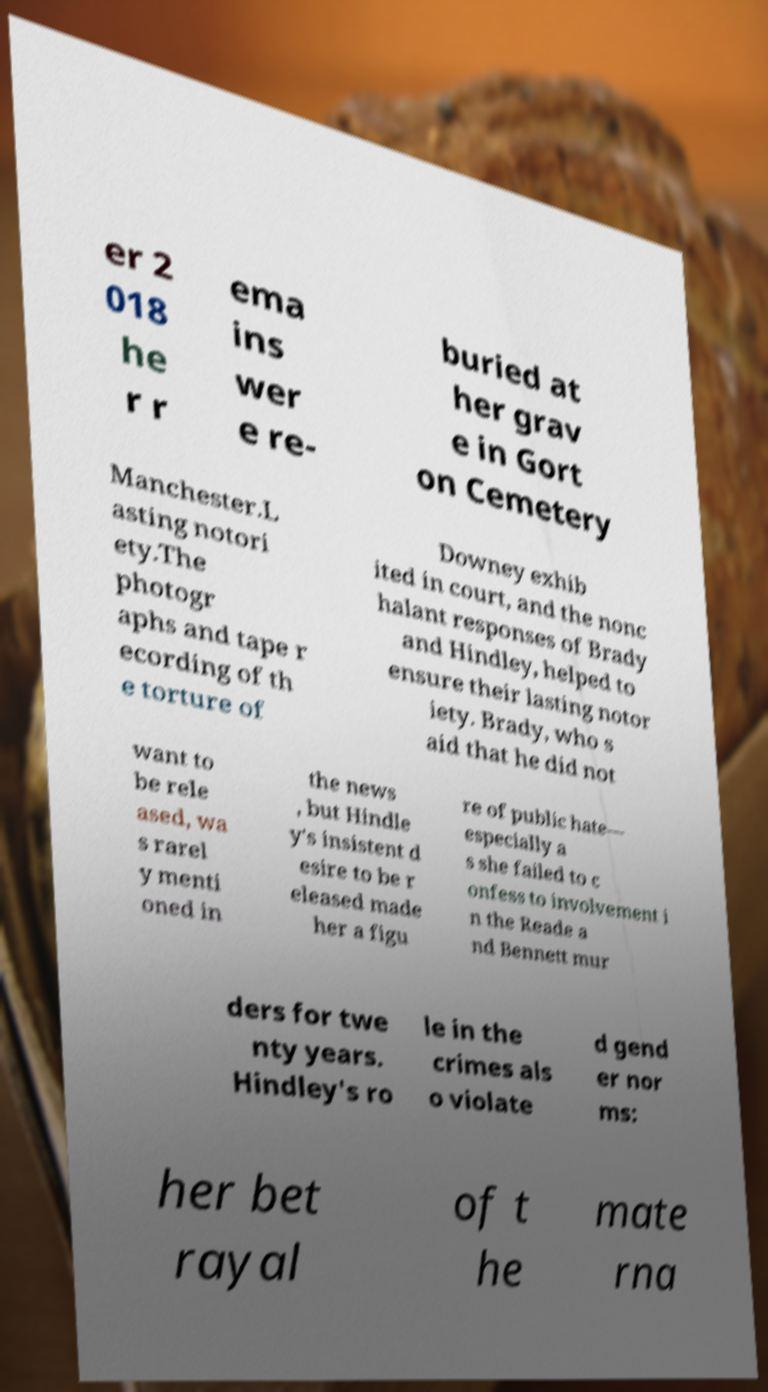Can you read and provide the text displayed in the image?This photo seems to have some interesting text. Can you extract and type it out for me? er 2 018 he r r ema ins wer e re- buried at her grav e in Gort on Cemetery Manchester.L asting notori ety.The photogr aphs and tape r ecording of th e torture of Downey exhib ited in court, and the nonc halant responses of Brady and Hindley, helped to ensure their lasting notor iety. Brady, who s aid that he did not want to be rele ased, wa s rarel y menti oned in the news , but Hindle y's insistent d esire to be r eleased made her a figu re of public hate— especially a s she failed to c onfess to involvement i n the Reade a nd Bennett mur ders for twe nty years. Hindley's ro le in the crimes als o violate d gend er nor ms: her bet rayal of t he mate rna 